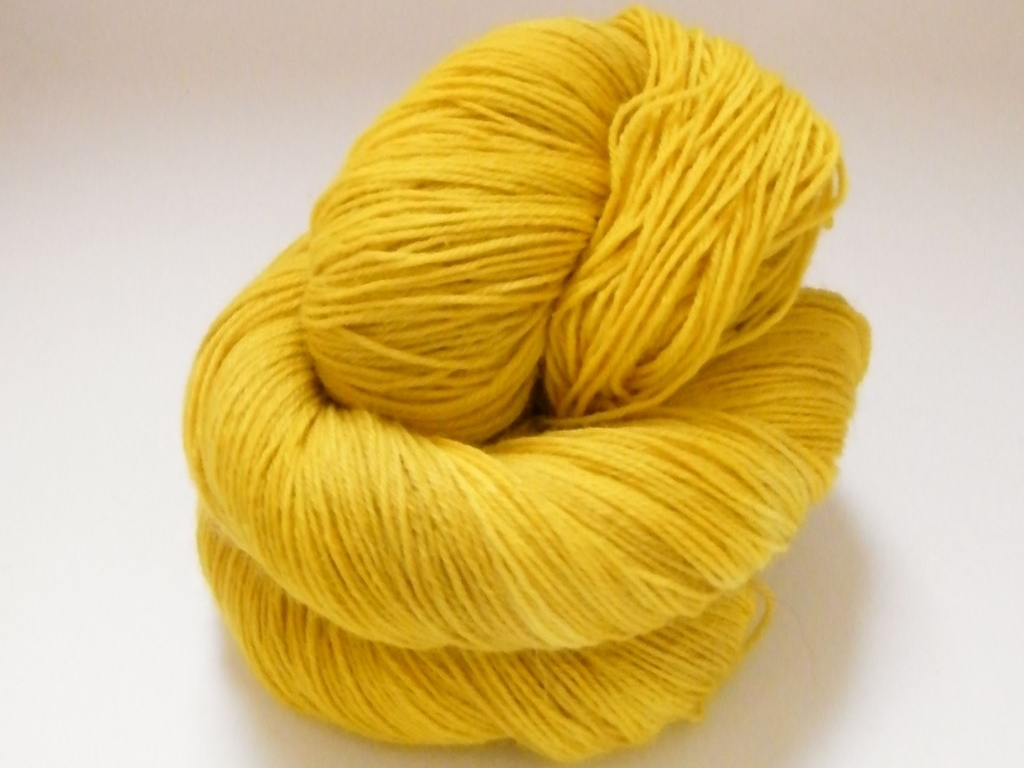Overall, how would you rate the image quality? The image quality appears to be very good, with the subject in sharp focus and the colors looking vibrant. The lighting is even, which helps to accentuate the texture of the yarn, and there's no visible noise or distortion that would detract from the overall clarity of the photograph. 